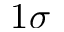Convert formula to latex. <formula><loc_0><loc_0><loc_500><loc_500>1 \sigma</formula> 